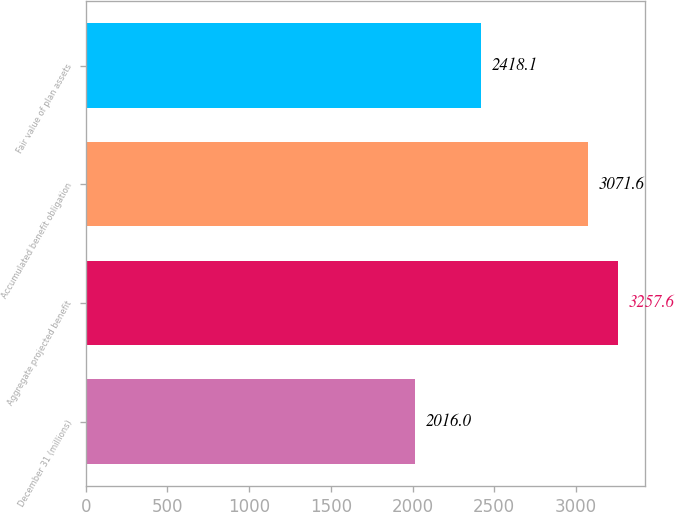<chart> <loc_0><loc_0><loc_500><loc_500><bar_chart><fcel>December 31 (millions)<fcel>Aggregate projected benefit<fcel>Accumulated benefit obligation<fcel>Fair value of plan assets<nl><fcel>2016<fcel>3257.6<fcel>3071.6<fcel>2418.1<nl></chart> 